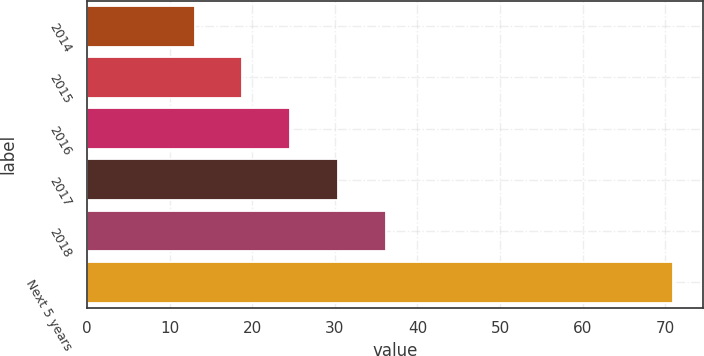Convert chart to OTSL. <chart><loc_0><loc_0><loc_500><loc_500><bar_chart><fcel>2014<fcel>2015<fcel>2016<fcel>2017<fcel>2018<fcel>Next 5 years<nl><fcel>13<fcel>18.8<fcel>24.6<fcel>30.4<fcel>36.2<fcel>71<nl></chart> 